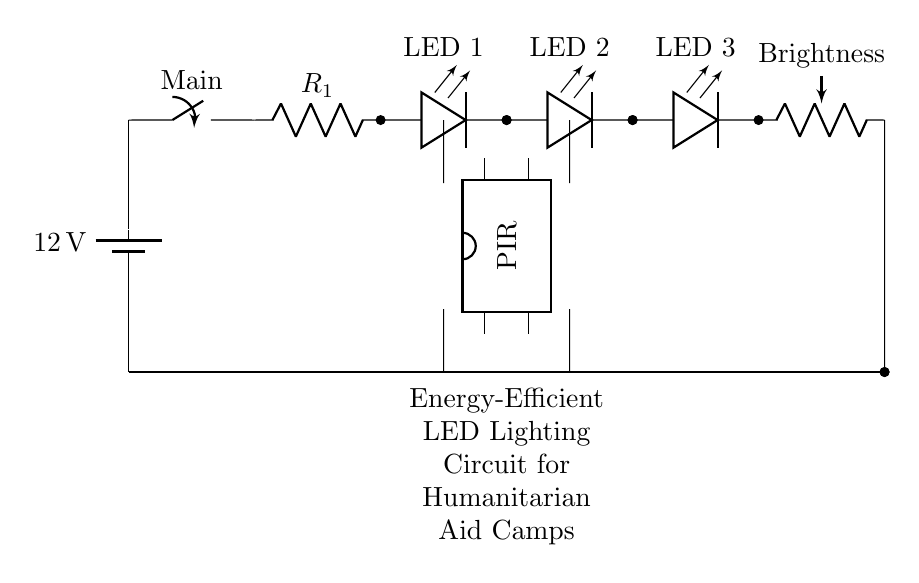What is the voltage of the power source? The circuit shows a battery labeled with a voltage of 12 volts connected at the beginning.
Answer: 12 volts What type of components are used to provide illumination? The circuit contains three LEDs, as represented by their symbols, each connected in series to provide light.
Answer: LEDs What is the purpose of the resistor in the circuit? The resistor is labeled as R1, which typically serves to limit the current flowing through the LEDs to prevent damage.
Answer: Current limiting How is brightness controlled in this circuit? The circuit includes a potentiometer labeled as Brightness, which adjusts the resistance and can vary the brightness of the LEDs by changing current flow.
Answer: Potentiometer Which component detects motion in the circuit? The circuit includes a PIR sensor positioned between the LED array and the power source, indicating its role in detecting motion to activate the lighting.
Answer: PIR sensor How many LEDs are in the array? The circuit diagram shows three LED components connected in series, labeled sequentially as LED 1, LED 2, and LED 3.
Answer: Three What kind of switch is used in this circuit? The switch is labeled as Main, which allows for the manual control of the circuit, enabling or disabling the power to the LEDs when activated.
Answer: Main switch 